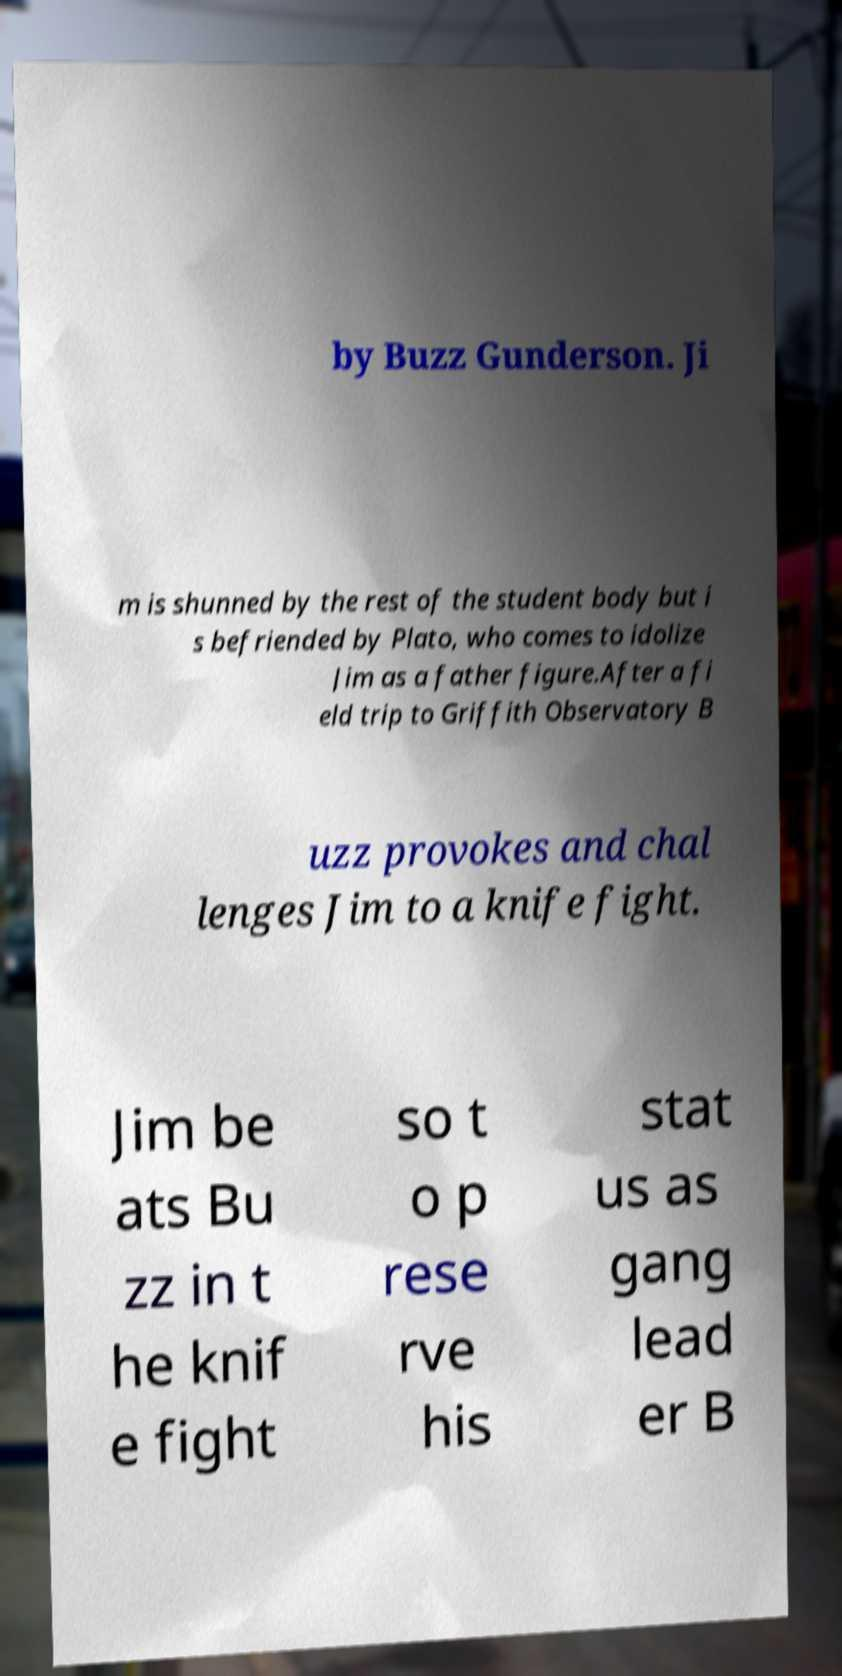Can you read and provide the text displayed in the image?This photo seems to have some interesting text. Can you extract and type it out for me? by Buzz Gunderson. Ji m is shunned by the rest of the student body but i s befriended by Plato, who comes to idolize Jim as a father figure.After a fi eld trip to Griffith Observatory B uzz provokes and chal lenges Jim to a knife fight. Jim be ats Bu zz in t he knif e fight so t o p rese rve his stat us as gang lead er B 